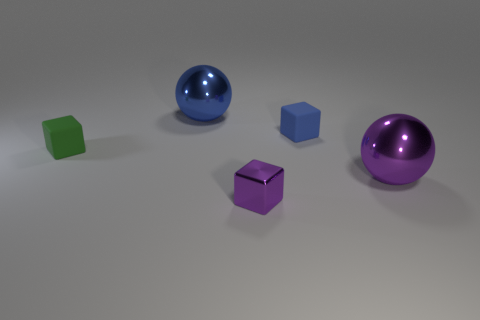Is the material of the ball in front of the blue matte thing the same as the blue cube that is to the right of the green thing?
Ensure brevity in your answer.  No. Does the large object in front of the blue cube have the same material as the tiny green block?
Your response must be concise. No. There is a shiny object that is right of the large blue object and to the left of the purple metallic ball; what color is it?
Provide a succinct answer. Purple. What is the shape of the large metallic object that is the same color as the small metal object?
Provide a succinct answer. Sphere. How big is the sphere that is on the left side of the big metallic object in front of the big blue shiny ball?
Offer a very short reply. Large. What number of balls are either blue matte objects or large metal objects?
Provide a short and direct response. 2. There is a rubber block that is the same size as the green matte object; what is its color?
Your answer should be very brief. Blue. There is a thing on the left side of the large shiny ball behind the small blue cube; what is its shape?
Give a very brief answer. Cube. There is a blue thing that is in front of the blue metallic thing; is its size the same as the big blue shiny sphere?
Offer a terse response. No. What number of other objects are the same material as the tiny green cube?
Provide a short and direct response. 1. 